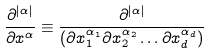<formula> <loc_0><loc_0><loc_500><loc_500>\frac { \partial ^ { | \alpha | } } { \partial x ^ { \alpha } } \equiv \frac { \partial ^ { | \alpha | } } { ( \partial x _ { 1 } ^ { \alpha _ { 1 } } \partial x _ { 2 } ^ { \alpha _ { 2 } } \dots \partial x _ { d } ^ { \alpha _ { d } } ) }</formula> 